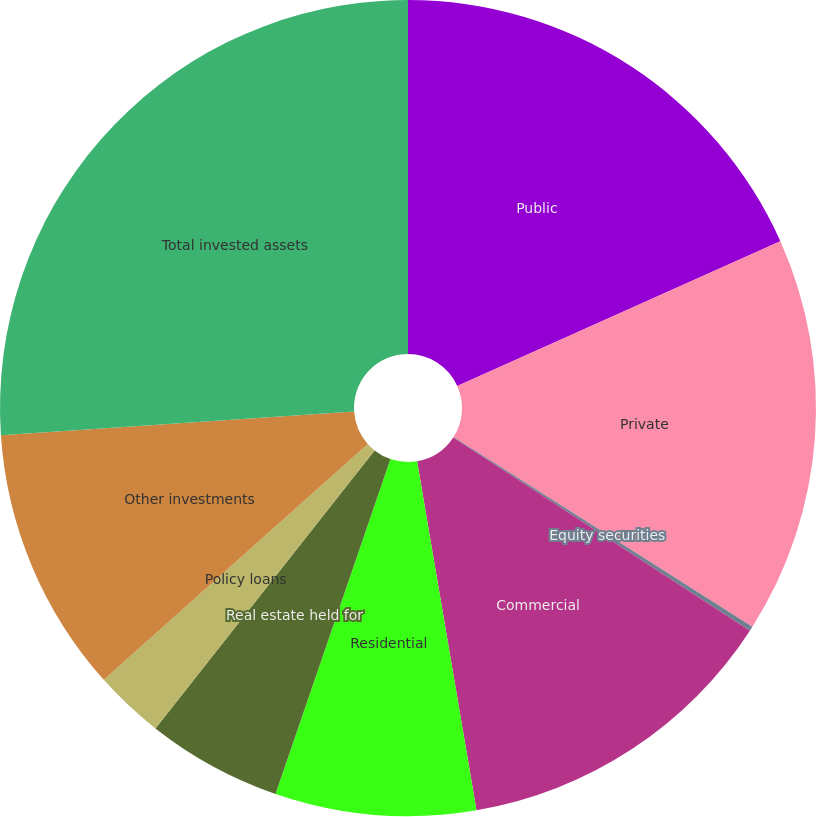Convert chart. <chart><loc_0><loc_0><loc_500><loc_500><pie_chart><fcel>Public<fcel>Private<fcel>Equity securities<fcel>Commercial<fcel>Residential<fcel>Real estate held for<fcel>Policy loans<fcel>Other investments<fcel>Total invested assets<nl><fcel>18.3%<fcel>15.71%<fcel>0.18%<fcel>13.13%<fcel>7.95%<fcel>5.36%<fcel>2.77%<fcel>10.54%<fcel>26.07%<nl></chart> 